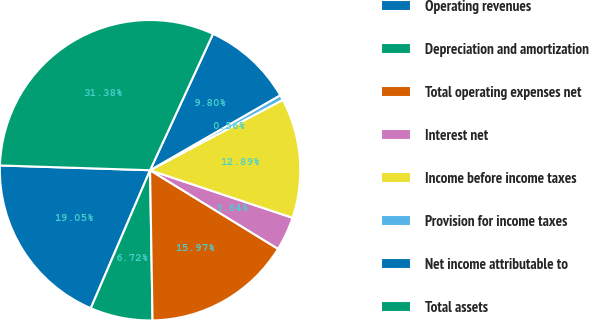<chart> <loc_0><loc_0><loc_500><loc_500><pie_chart><fcel>Operating revenues<fcel>Depreciation and amortization<fcel>Total operating expenses net<fcel>Interest net<fcel>Income before income taxes<fcel>Provision for income taxes<fcel>Net income attributable to<fcel>Total assets<nl><fcel>19.05%<fcel>6.72%<fcel>15.97%<fcel>3.64%<fcel>12.89%<fcel>0.56%<fcel>9.8%<fcel>31.38%<nl></chart> 